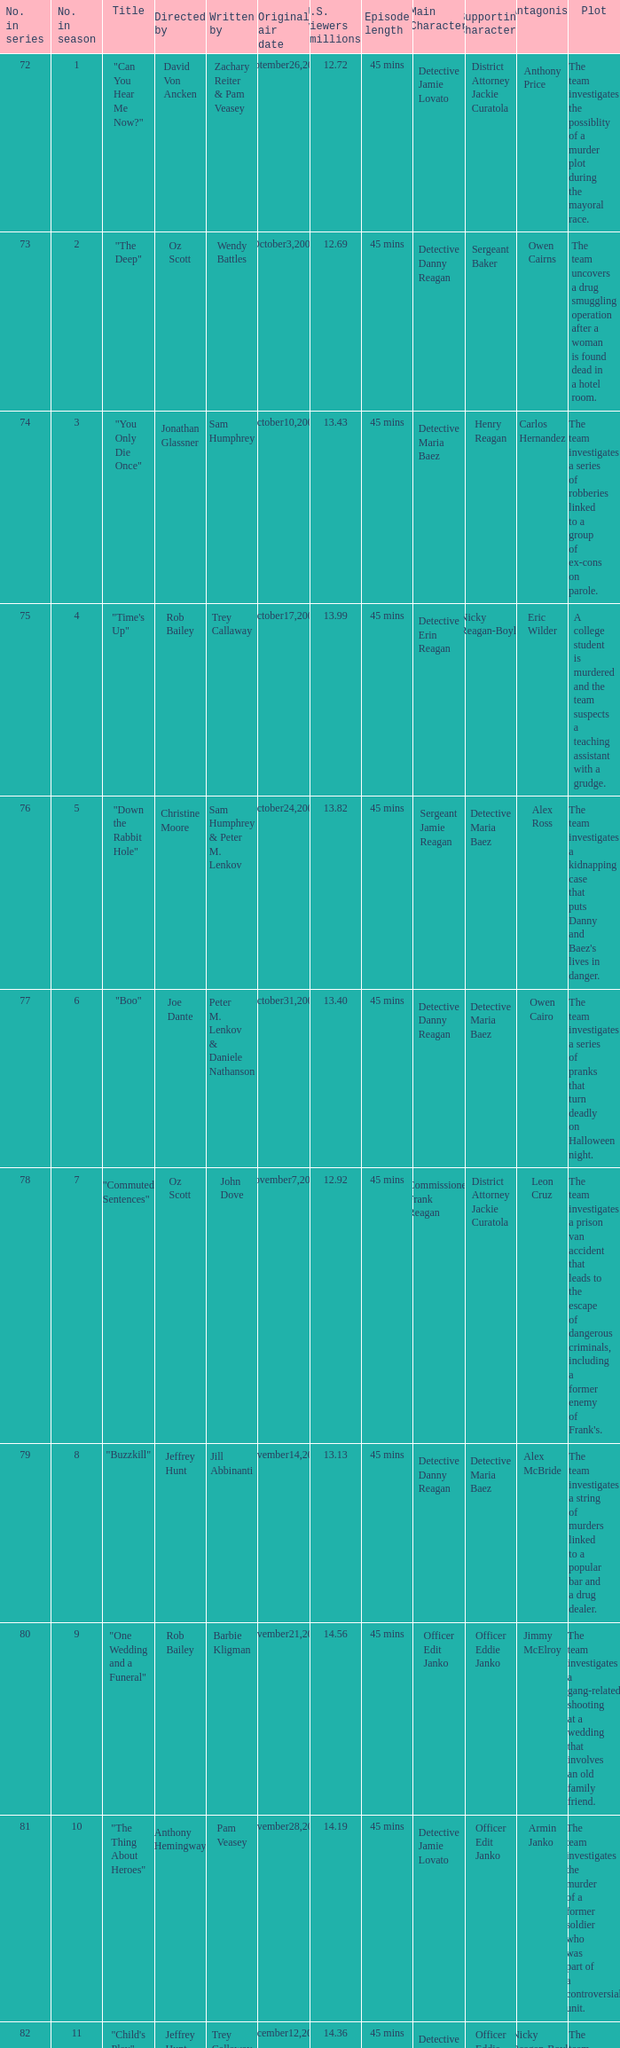Parse the full table. {'header': ['No. in series', 'No. in season', 'Title', 'Directed by', 'Written by', 'Original air date', 'U.S. viewers (millions)', 'Episode length', 'Main Character', 'Supporting Character', 'Antagonist', 'Plot'], 'rows': [['72', '1', '"Can You Hear Me Now?"', 'David Von Ancken', 'Zachary Reiter & Pam Veasey', 'September26,2007', '12.72', '45 mins', 'Detective Jamie Lovato', 'District Attorney Jackie Curatola', 'Anthony Price', 'The team investigates the possiblity of a murder plot during the mayoral race.'], ['73', '2', '"The Deep"', 'Oz Scott', 'Wendy Battles', 'October3,2007', '12.69', '45 mins', 'Detective Danny Reagan', 'Sergeant Baker', 'Owen Cairns', 'The team uncovers a drug smuggling operation after a woman is found dead in a hotel room.'], ['74', '3', '"You Only Die Once"', 'Jonathan Glassner', 'Sam Humphrey', 'October10,2007', '13.43', '45 mins', 'Detective Maria Baez', 'Henry Reagan', 'Carlos Hernandez', 'The team investigates a series of robberies linked to a group of ex-cons on parole.'], ['75', '4', '"Time\'s Up"', 'Rob Bailey', 'Trey Callaway', 'October17,2007', '13.99', '45 mins', 'Detective Erin Reagan', 'Nicky Reagan-Boyle', 'Eric Wilder', 'A college student is murdered and the team suspects a teaching assistant with a grudge.'], ['76', '5', '"Down the Rabbit Hole"', 'Christine Moore', 'Sam Humphrey & Peter M. Lenkov', 'October24,2007', '13.82', '45 mins', 'Sergeant Jamie Reagan', 'Detective Maria Baez', 'Alex Ross', "The team investigates a kidnapping case that puts Danny and Baez's lives in danger."], ['77', '6', '"Boo"', 'Joe Dante', 'Peter M. Lenkov & Daniele Nathanson', 'October31,2007', '13.40', '45 mins', 'Detective Danny Reagan', 'Detective Maria Baez', 'Owen Cairo', 'The team investigates a series of pranks that turn deadly on Halloween night.'], ['78', '7', '"Commuted Sentences"', 'Oz Scott', 'John Dove', 'November7,2007', '12.92', '45 mins', 'Commissioner Frank Reagan', 'District Attorney Jackie Curatola', 'Leon Cruz', "The team investigates a prison van accident that leads to the escape of dangerous criminals, including a former enemy of Frank's."], ['79', '8', '"Buzzkill"', 'Jeffrey Hunt', 'Jill Abbinanti', 'November14,2007', '13.13', '45 mins', 'Detective Danny Reagan', 'Detective Maria Baez', 'Alex McBride', 'The team investigates a string of murders linked to a popular bar and a drug dealer.'], ['80', '9', '"One Wedding and a Funeral"', 'Rob Bailey', 'Barbie Kligman', 'November21,2007', '14.56', '45 mins', 'Officer Edit Janko', 'Officer Eddie Janko', 'Jimmy McElroy', 'The team investigates a gang-related shooting at a wedding that involves an old family friend.'], ['81', '10', '"The Thing About Heroes"', 'Anthony Hemingway', 'Pam Veasey', 'November28,2007', '14.19', '45 mins', 'Detective Jamie Lovato', 'Officer Edit Janko', 'Armin Janko', 'The team investigates the murder of a former soldier who was part of a controversial unit.'], ['82', '11', '"Child\'s Play"', 'Jeffrey Hunt', 'Trey Callaway & Pam Veasey', 'December12,2007', '14.36', '45 mins', 'Detective Maria Baez', 'Officer Eddie Janko', 'Nicky Reagan-Boyle', 'The team investigates the murder of a toy company executive and uncovers a feud between the victim and her siblings.'], ['83', '12', '"Happily Never After"', 'Marshall Adams', 'Daniele Nathanson & Noah Nelson', 'January9,2008', '11.71', '45 mins', 'Detective Danny Reagan', 'Detective Maria Baez', 'Eddie Marquez', 'The team investigates the murder of a bride-to-be and discovers a connection to a series of unsolved homicides.'], ['84', '13', '"All in the Family"', 'Rob Bailey', 'Wendy Battles', 'January23,2008', '11.51', '45 mins', 'Commissioner Frank Reagan', 'Detective Danny Reagan', 'Katherine Tucker', "Frank's neighbor is arrested for possession and the team uncovers a larger drug operation with ties to the neighborhood."], ['85', '14', '"Playing With Matches"', 'Christine Moore', 'Bill Haynes', 'February6,2008', '10.16', '45 mins', 'Detective Maria Baez', 'Officer Eddie Janko', 'Gary Heller', 'The team investigates a fire at a local boxing gym and discovers a connection to organized crime.'], ['86', '15', '"DOA For a Day"', 'Christine Moore', 'Peter M. Lenkov & John Dove', 'April2,2008', '12.85', '45 mins', 'Detective Erin Reagan', 'Detective Anthony Abetemarco', 'Johnny Tesla', "The team investigates a murder at a popular tourist spot and uncovers a conspiracy within the victim's own family."], ['87', '16', '"Right Next Door"', 'Rob Bailey', 'Pam Veasey', 'April9,2008', '12.38', '45 mins', 'Detective Danny Reagan', 'Detective Maria Baez', 'Trent Bowden', "The team investigates a murder in a wealthy suburban neighborhood and uncovers a dark secret about the victim's family."], ['88', '17', '"Like Water For Murder"', 'Anthony Hemingway', 'Sam Humphrey', 'April16,2008', '13.43', '45 mins', 'Officer Edit Janko', 'Officer Eddie Janko', 'Andy Powell', 'The team investigates a murder at a high-end spa and uncovers a web of lies and secret relationships among its staff.'], ['89', '18', '"Admissions"', 'Rob Bailey', 'Zachary Reiter', 'April30,2008', '11.51', '45 mins', 'Detective Jamie Lovato', 'Sergeant Gormley', 'Malcolm Cleary', 'The team investigates a murder at a prestigious private school and uncovers a competition between parents to get their children into elite colleges.'], ['90', '19', '"Personal Foul"', 'David Von Ancken', 'Trey Callaway', 'May7,2008', '12.73', '45 mins', 'Detective Maria Baez', 'Sergeant Jamie Reagan', 'Ed Gormley Jr.', "The team investigates a dirty cop who has ties to Danny's past and may be connected to a series of murders."], ['91', '20', '"Taxi"', 'Christine Moore', 'Barbie Kligman & John Dove', 'May14,2008', '11.86', '45 mins', 'Detective Danny Reagan', 'Detective Maria Baez', 'Freddy Ramirez', 'The team investigates a taxi cab company that may be involved in drug trafficking and the murder of one of its drivers.']]} How many millions of U.S. viewers watched the episode directed by Rob Bailey and written by Pam Veasey? 12.38. 